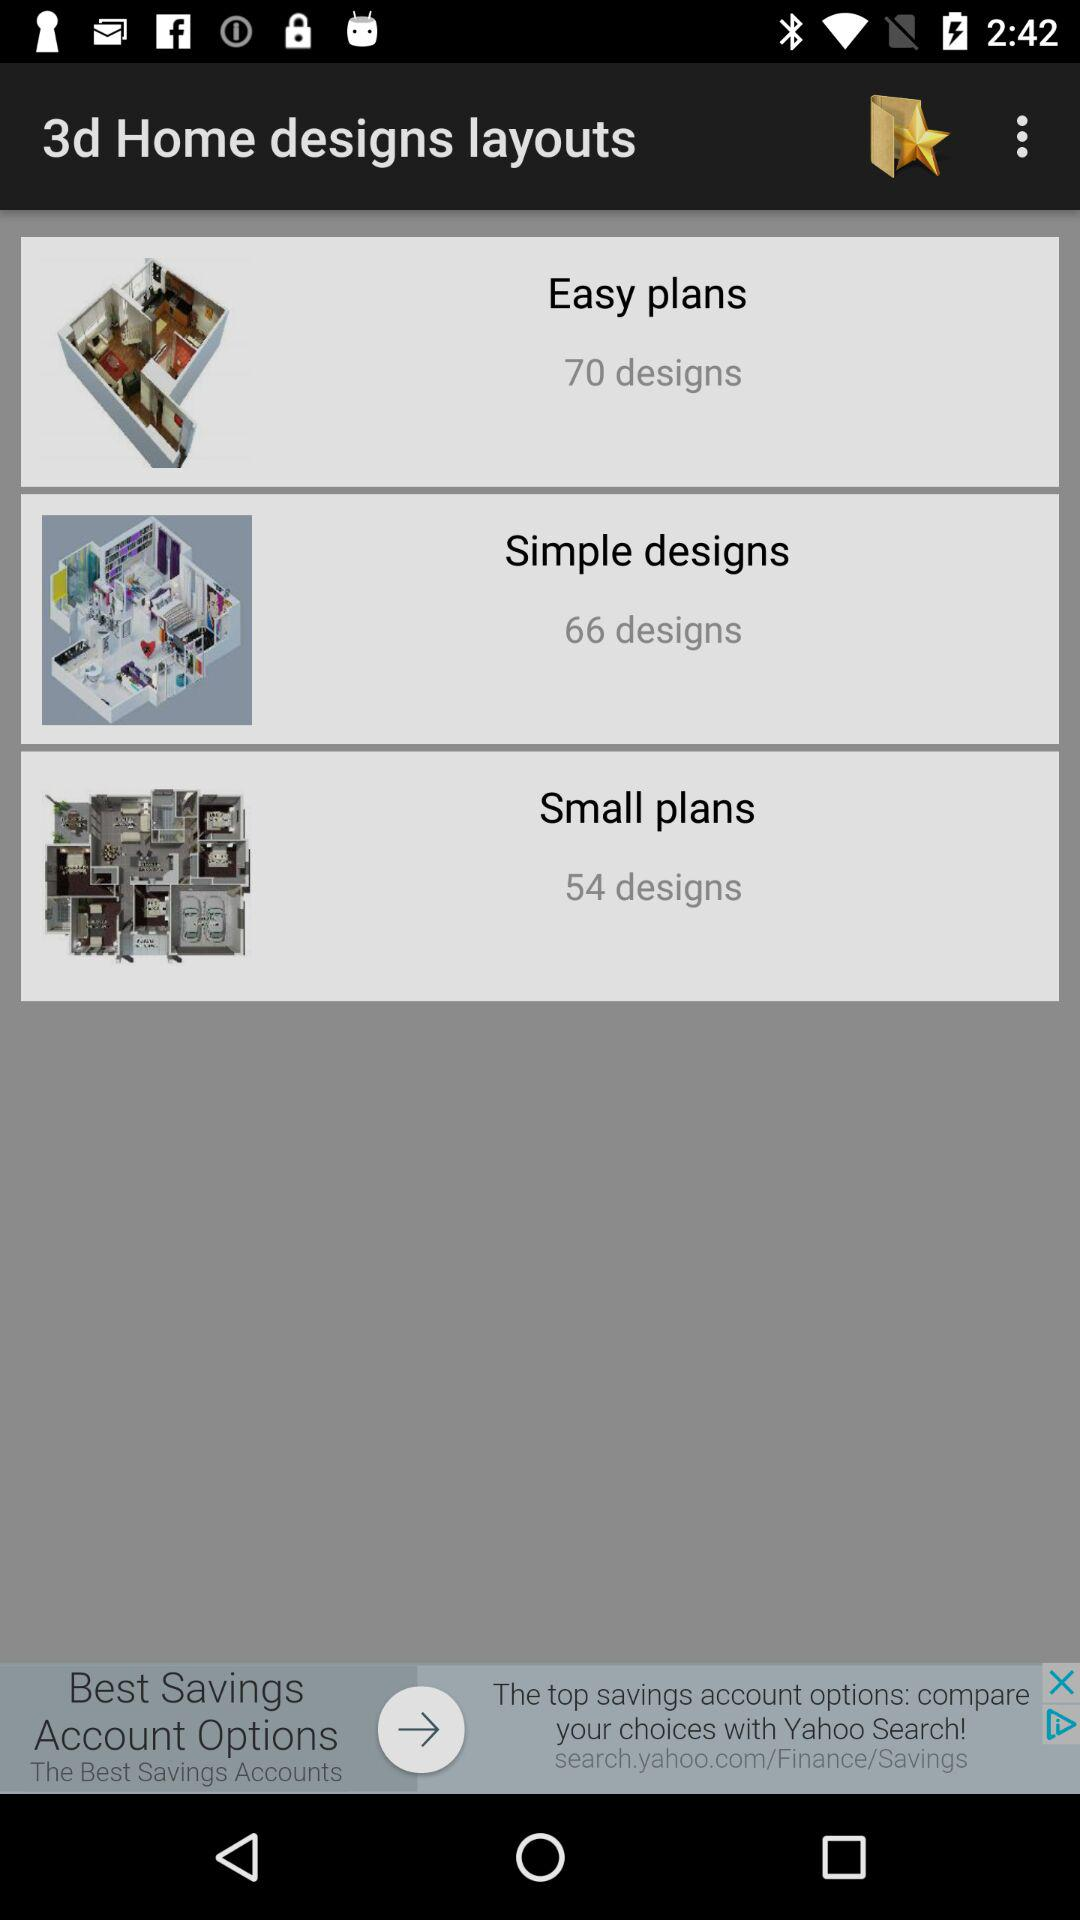What is the number of designs in "Easy plans"? The number of designs in "Easy plans" is 70. 